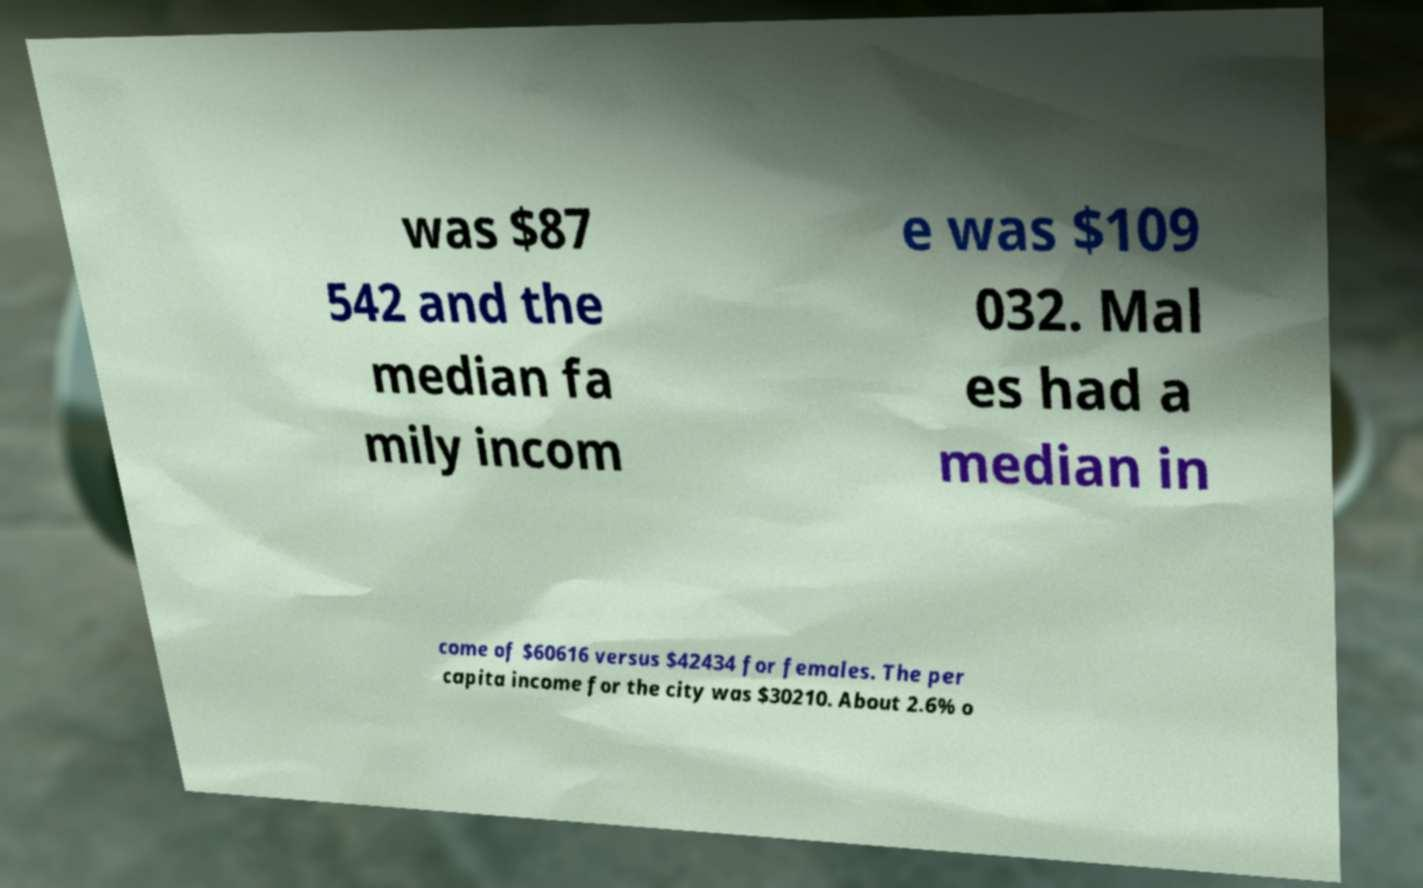Could you assist in decoding the text presented in this image and type it out clearly? was $87 542 and the median fa mily incom e was $109 032. Mal es had a median in come of $60616 versus $42434 for females. The per capita income for the city was $30210. About 2.6% o 